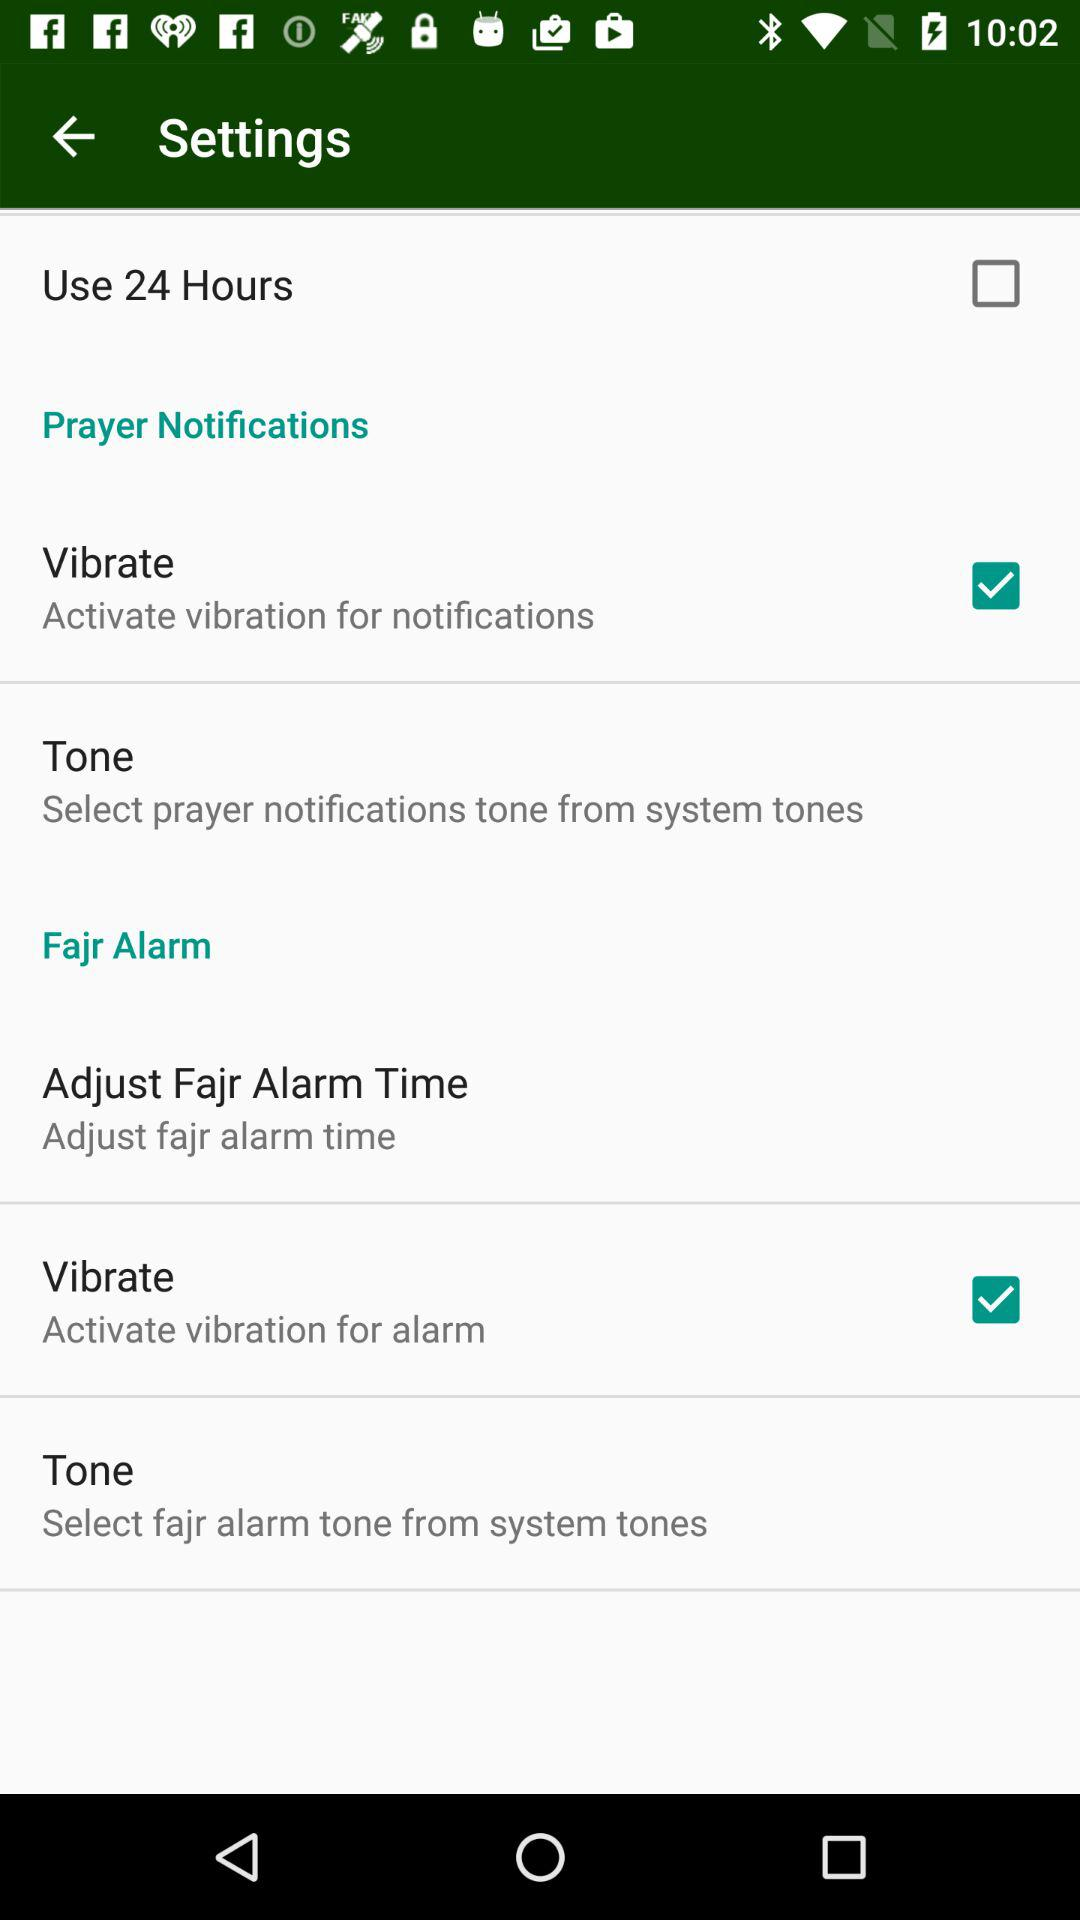What is the status of the "Use 24 Hours"? The status is "off". 